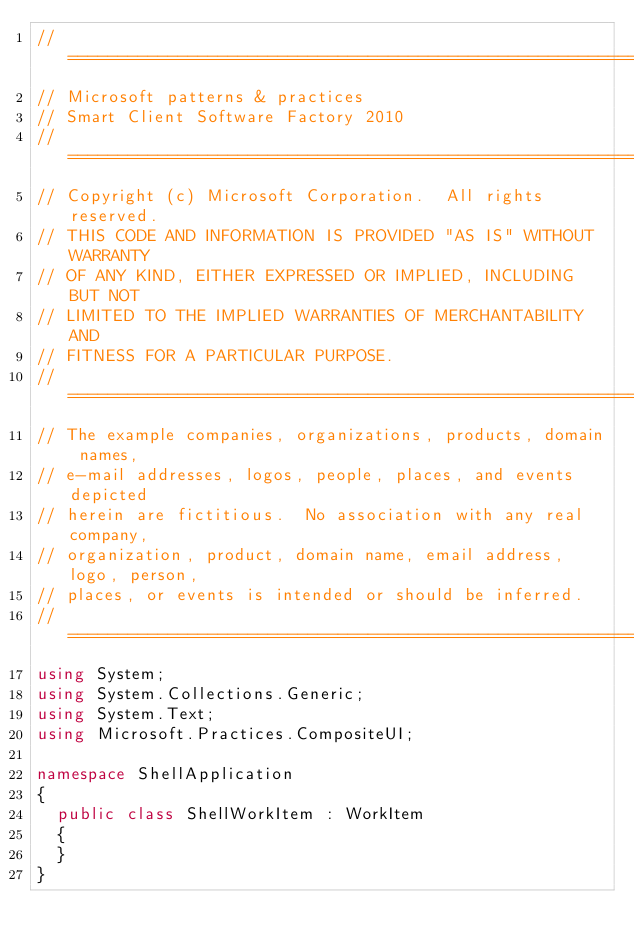<code> <loc_0><loc_0><loc_500><loc_500><_C#_>//===============================================================================
// Microsoft patterns & practices
// Smart Client Software Factory 2010
//===============================================================================
// Copyright (c) Microsoft Corporation.  All rights reserved.
// THIS CODE AND INFORMATION IS PROVIDED "AS IS" WITHOUT WARRANTY
// OF ANY KIND, EITHER EXPRESSED OR IMPLIED, INCLUDING BUT NOT
// LIMITED TO THE IMPLIED WARRANTIES OF MERCHANTABILITY AND
// FITNESS FOR A PARTICULAR PURPOSE.
//===============================================================================
// The example companies, organizations, products, domain names,
// e-mail addresses, logos, people, places, and events depicted
// herein are fictitious.  No association with any real company,
// organization, product, domain name, email address, logo, person,
// places, or events is intended or should be inferred.
//===============================================================================
using System;
using System.Collections.Generic;
using System.Text;
using Microsoft.Practices.CompositeUI;

namespace ShellApplication
{
	public class ShellWorkItem : WorkItem
	{
	}
}
</code> 